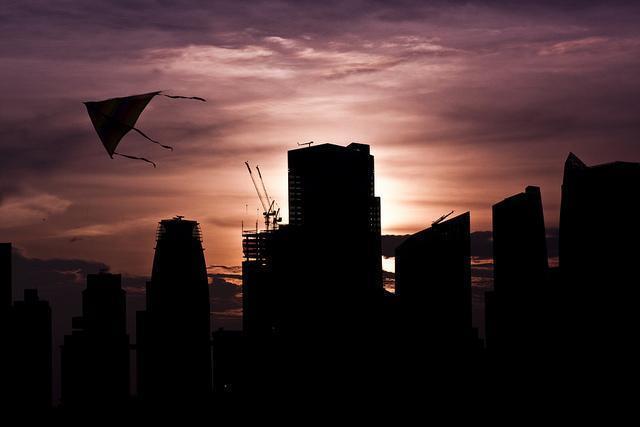How many cats have gray on their fur?
Give a very brief answer. 0. 